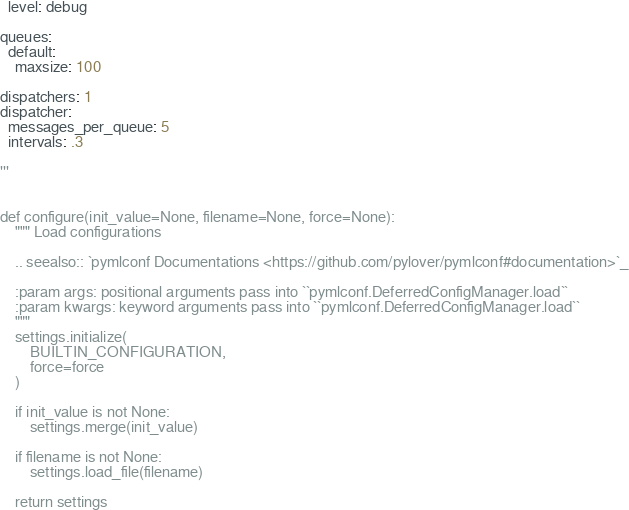<code> <loc_0><loc_0><loc_500><loc_500><_Python_>  level: debug

queues:
  default:
    maxsize: 100

dispatchers: 1
dispatcher:
  messages_per_queue: 5
  intervals: .3

'''


def configure(init_value=None, filename=None, force=None):
    """ Load configurations

    .. seealso:: `pymlconf Documentations <https://github.com/pylover/pymlconf#documentation>`_

    :param args: positional arguments pass into ``pymlconf.DeferredConfigManager.load``
    :param kwargs: keyword arguments pass into ``pymlconf.DeferredConfigManager.load``
    """
    settings.initialize(
        BUILTIN_CONFIGURATION,
        force=force
    )

    if init_value is not None:
        settings.merge(init_value)

    if filename is not None:
        settings.load_file(filename)

    return settings

</code> 